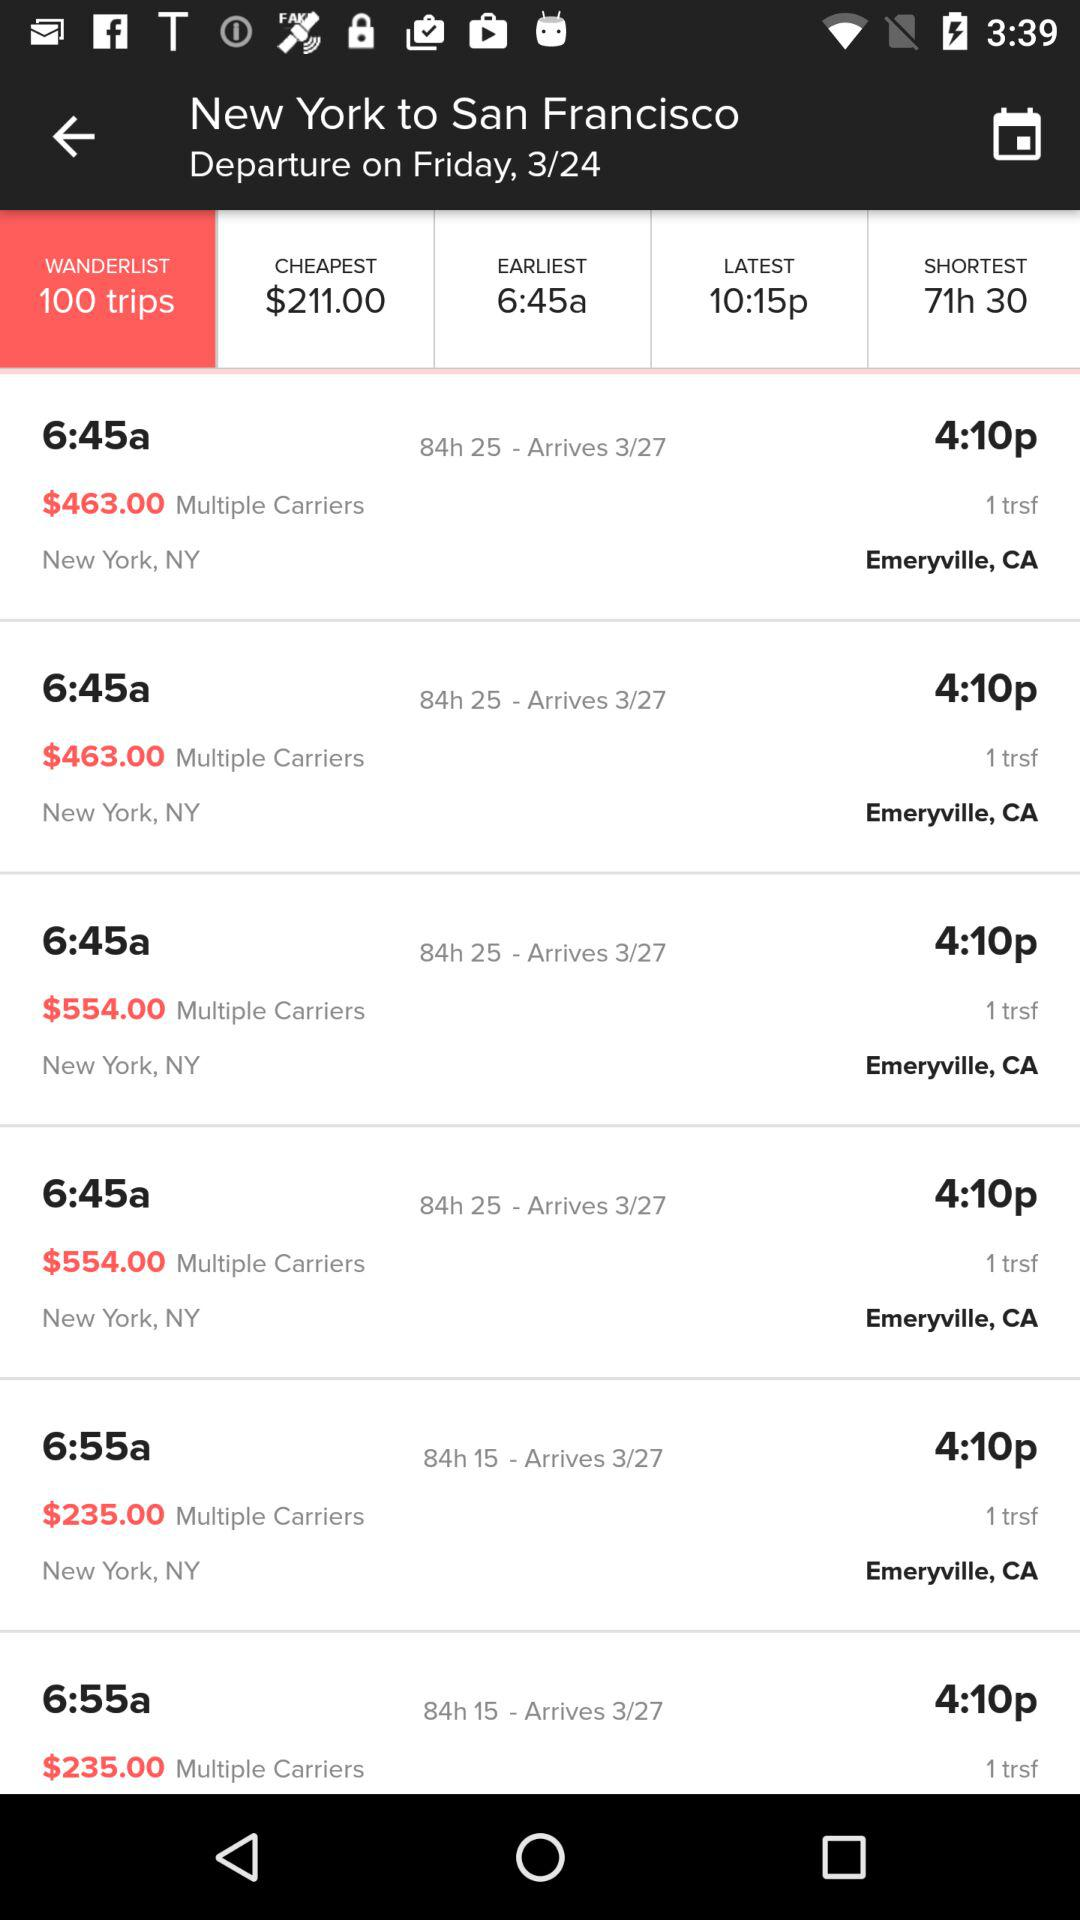At what time will the flight depart? The flights will depart at 6:45 a.m. and 6:55 a.m. 